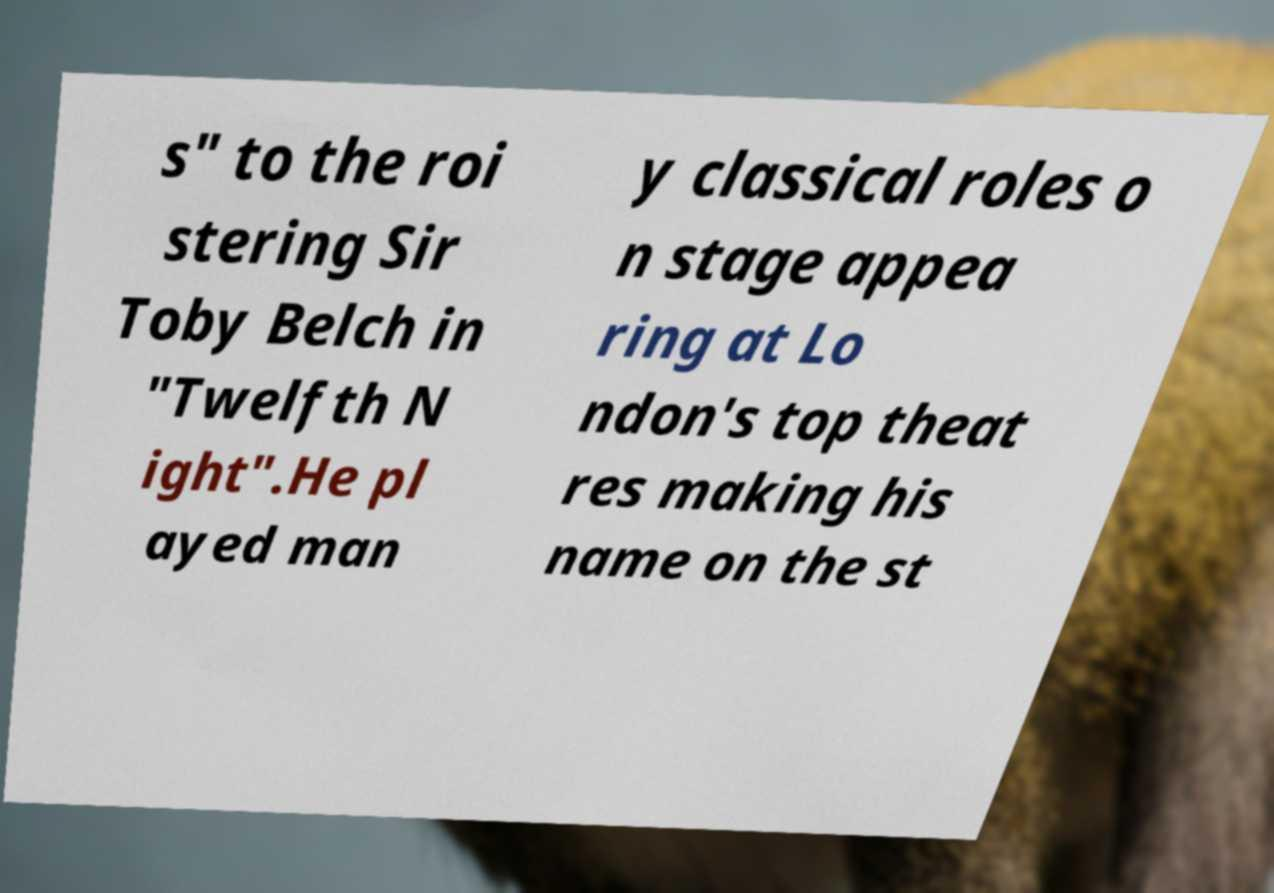I need the written content from this picture converted into text. Can you do that? s" to the roi stering Sir Toby Belch in "Twelfth N ight".He pl ayed man y classical roles o n stage appea ring at Lo ndon's top theat res making his name on the st 